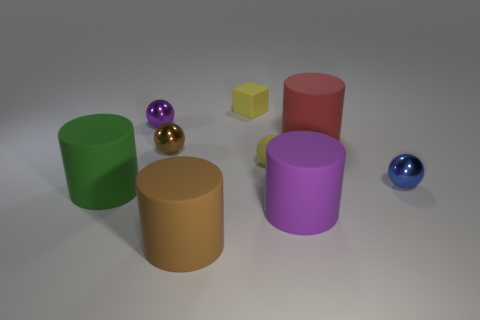Add 1 red things. How many objects exist? 10 Subtract 1 balls. How many balls are left? 3 Subtract all yellow spheres. How many spheres are left? 3 Subtract all rubber spheres. How many spheres are left? 3 Subtract all green balls. Subtract all purple cylinders. How many balls are left? 4 Subtract all spheres. How many objects are left? 5 Subtract 1 purple spheres. How many objects are left? 8 Subtract all big blue rubber cylinders. Subtract all shiny balls. How many objects are left? 6 Add 7 tiny rubber cubes. How many tiny rubber cubes are left? 8 Add 7 small metallic things. How many small metallic things exist? 10 